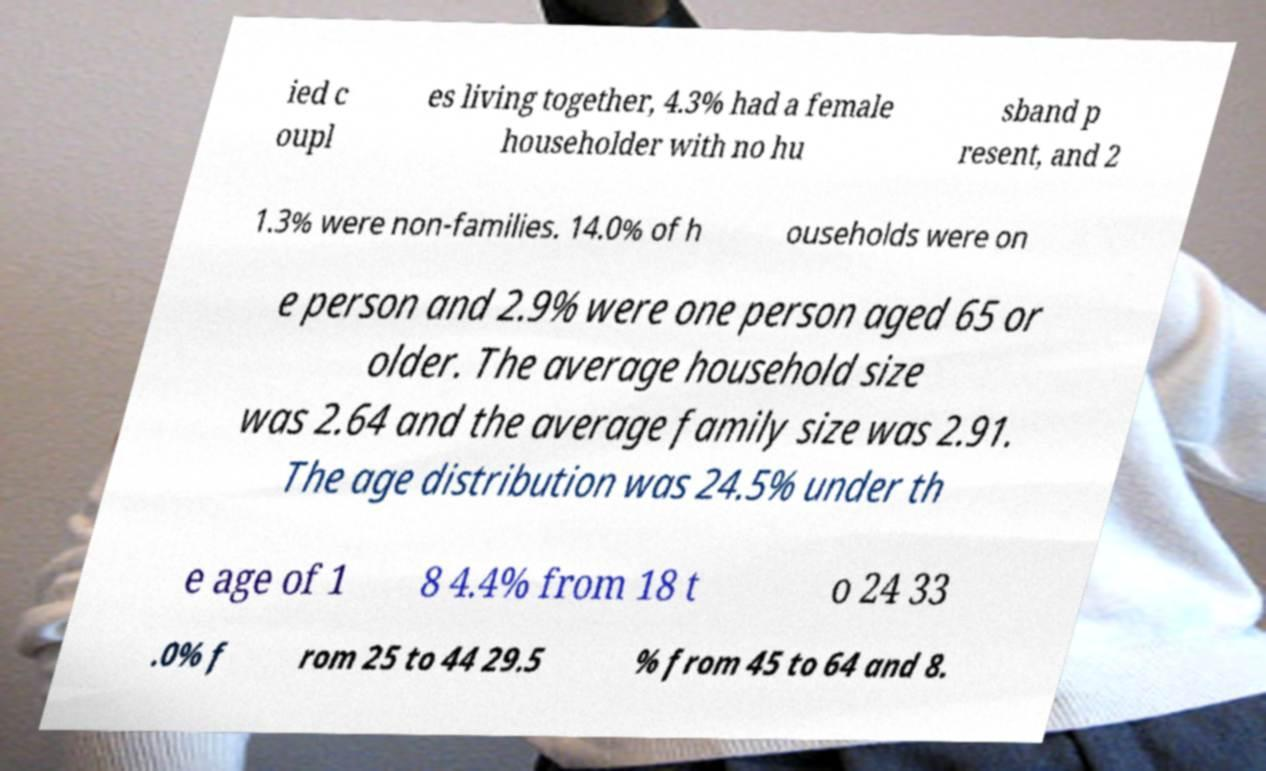There's text embedded in this image that I need extracted. Can you transcribe it verbatim? ied c oupl es living together, 4.3% had a female householder with no hu sband p resent, and 2 1.3% were non-families. 14.0% of h ouseholds were on e person and 2.9% were one person aged 65 or older. The average household size was 2.64 and the average family size was 2.91. The age distribution was 24.5% under th e age of 1 8 4.4% from 18 t o 24 33 .0% f rom 25 to 44 29.5 % from 45 to 64 and 8. 